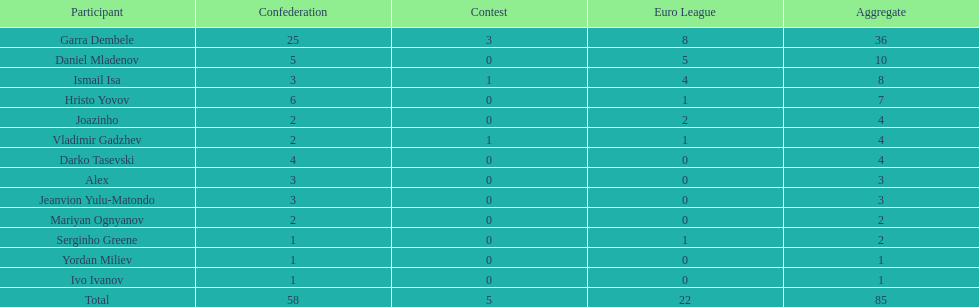Who had the most goal scores? Garra Dembele. 